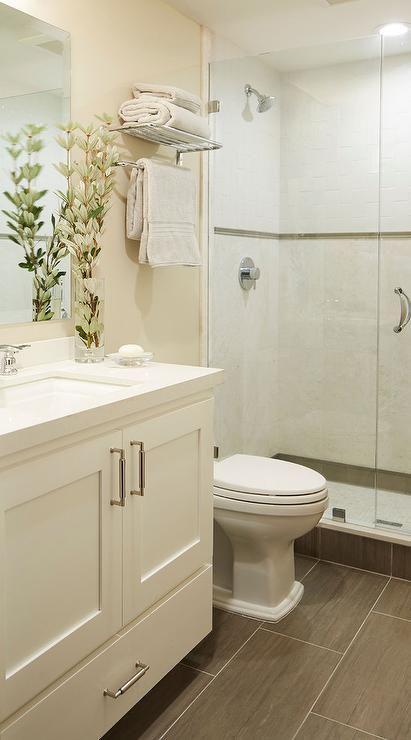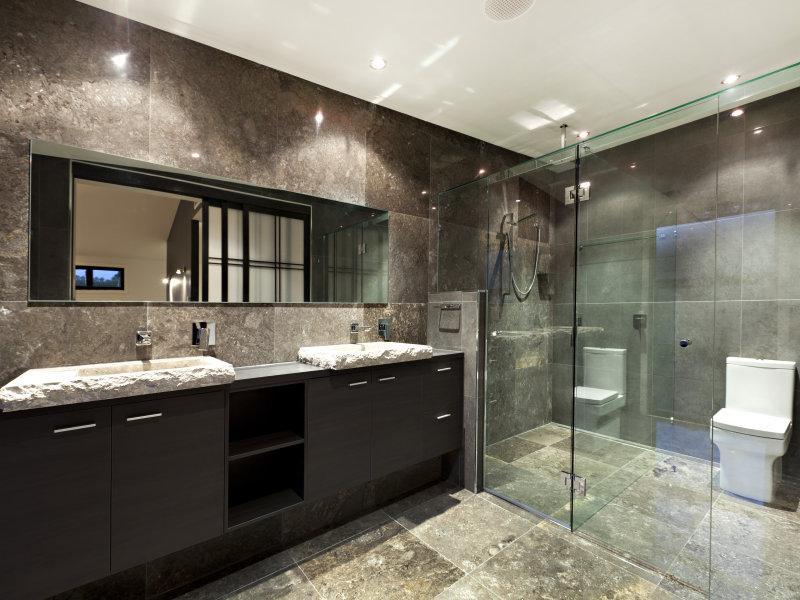The first image is the image on the left, the second image is the image on the right. For the images shown, is this caption "In one image, a shower stall is on the far end of a bathroom that also features a light colored vanity with one drawer and two doors." true? Answer yes or no. Yes. The first image is the image on the left, the second image is the image on the right. Given the left and right images, does the statement "The left image shows a dark vanity with a lighter countertop containing one inset sink with a faucet that is not wall-mounted, next to a traditional toilet with a tank." hold true? Answer yes or no. No. 